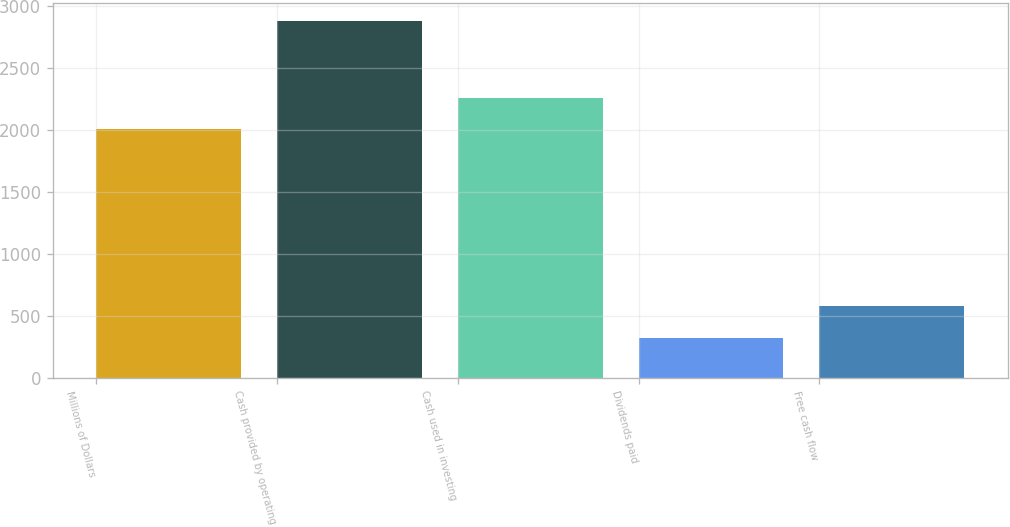Convert chart. <chart><loc_0><loc_0><loc_500><loc_500><bar_chart><fcel>Millions of Dollars<fcel>Cash provided by operating<fcel>Cash used in investing<fcel>Dividends paid<fcel>Free cash flow<nl><fcel>2006<fcel>2880<fcel>2261.8<fcel>322<fcel>577.8<nl></chart> 